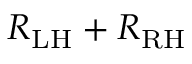Convert formula to latex. <formula><loc_0><loc_0><loc_500><loc_500>R _ { L H } + R _ { R H }</formula> 